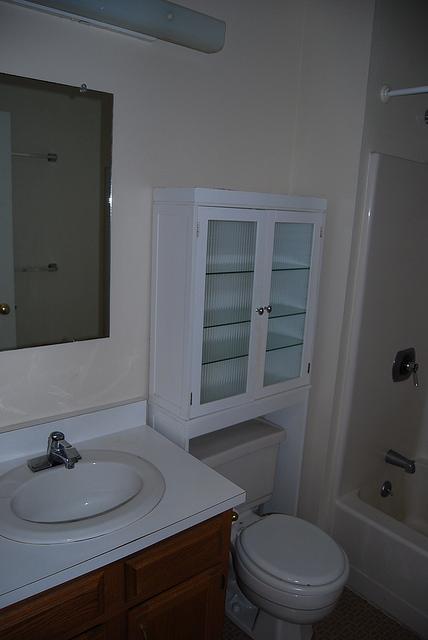Is there a razor on the counter?
Quick response, please. No. Is this in a home?
Keep it brief. Yes. How many towels are on the rack above the toilet?
Keep it brief. 0. Is there soap on the counter?
Short answer required. No. Is the countertop empty?
Short answer required. Yes. How many cabinet spaces?
Quick response, please. 8. Are these called his and hers sinks?
Concise answer only. No. Is this bathroom handicap accessible?
Write a very short answer. No. Is the light switch on?
Answer briefly. No. Would you clean the cabinet panels with furniture polish or window cleaner?
Be succinct. Window cleaner. How many shelves are in the cabinet with the glass doors?
Short answer required. 3. Is the bathroom currently occupied?
Write a very short answer. No. What is this room called?
Write a very short answer. Bathroom. What is on the wall?
Quick response, please. Mirror. What color are the walls?
Quick response, please. White. What is the sink sitting closest to?
Give a very brief answer. Toilet. What is sitting above the toilet tank?
Give a very brief answer. Cabinet. What is countertop color?
Be succinct. White. Is the sink pedestal-style?
Keep it brief. No. What shape is on the title to the right of the spigot?
Short answer required. Rectangle. Is there a hair dryer on top of the cabinet?
Short answer required. No. Is the toilet seat up or down?
Concise answer only. Down. Are the lights on?
Concise answer only. No. Is the toilet seat cover up or down?
Concise answer only. Down. Is there soap on the sink?
Write a very short answer. No. Is something plugged in?
Answer briefly. No. 